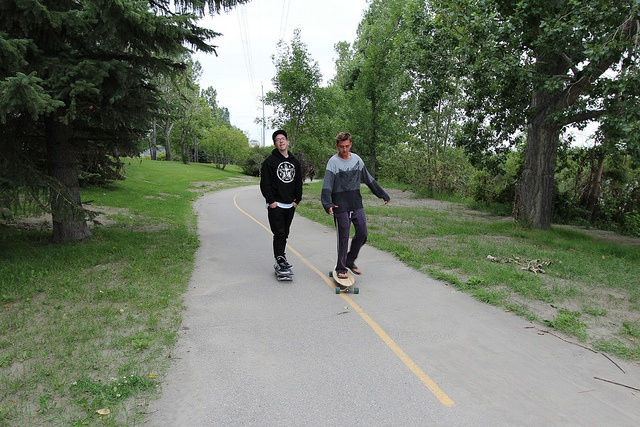Describe the objects in this image and their specific colors. I can see people in black, gray, and darkgray tones, people in black, gray, and darkgray tones, skateboard in black, tan, darkgray, and gray tones, skateboard in black, gray, darkgray, and navy tones, and people in black, gray, and darkgreen tones in this image. 